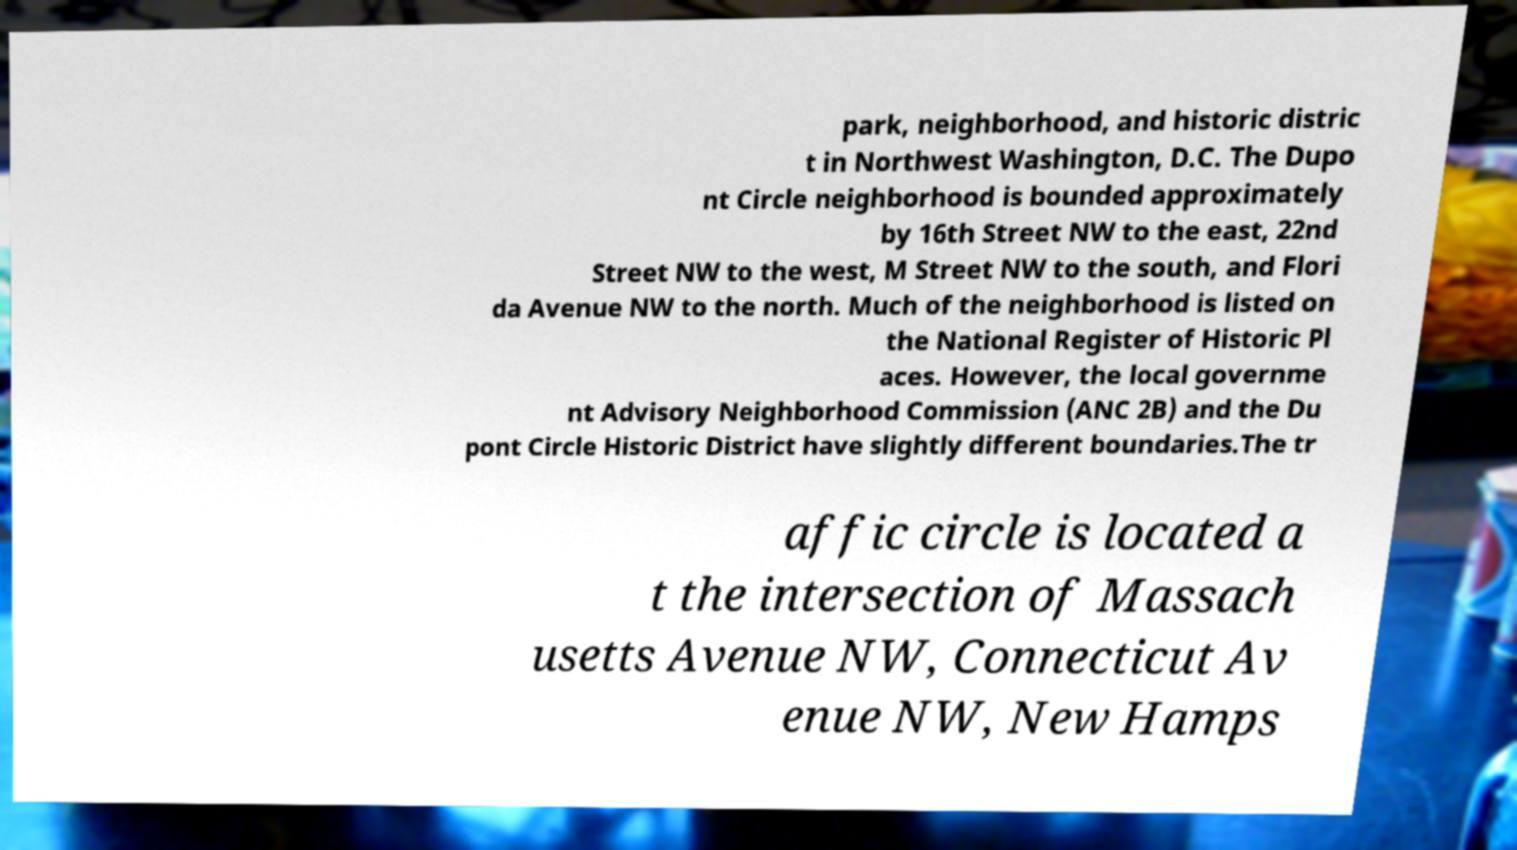Please identify and transcribe the text found in this image. park, neighborhood, and historic distric t in Northwest Washington, D.C. The Dupo nt Circle neighborhood is bounded approximately by 16th Street NW to the east, 22nd Street NW to the west, M Street NW to the south, and Flori da Avenue NW to the north. Much of the neighborhood is listed on the National Register of Historic Pl aces. However, the local governme nt Advisory Neighborhood Commission (ANC 2B) and the Du pont Circle Historic District have slightly different boundaries.The tr affic circle is located a t the intersection of Massach usetts Avenue NW, Connecticut Av enue NW, New Hamps 